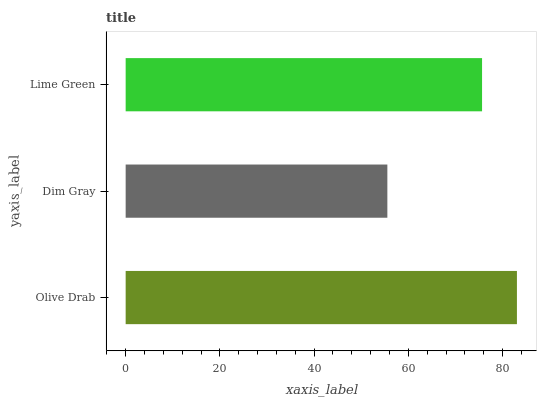Is Dim Gray the minimum?
Answer yes or no. Yes. Is Olive Drab the maximum?
Answer yes or no. Yes. Is Lime Green the minimum?
Answer yes or no. No. Is Lime Green the maximum?
Answer yes or no. No. Is Lime Green greater than Dim Gray?
Answer yes or no. Yes. Is Dim Gray less than Lime Green?
Answer yes or no. Yes. Is Dim Gray greater than Lime Green?
Answer yes or no. No. Is Lime Green less than Dim Gray?
Answer yes or no. No. Is Lime Green the high median?
Answer yes or no. Yes. Is Lime Green the low median?
Answer yes or no. Yes. Is Dim Gray the high median?
Answer yes or no. No. Is Dim Gray the low median?
Answer yes or no. No. 